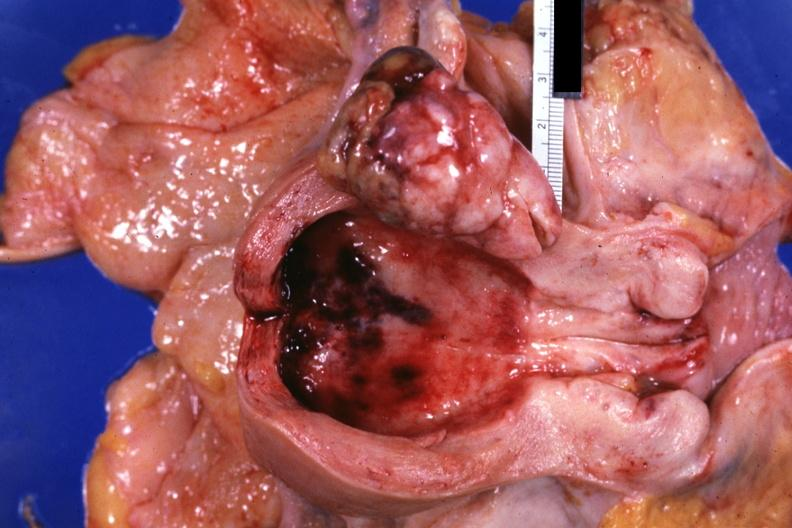s mixed mesodermal tumor present?
Answer the question using a single word or phrase. Yes 